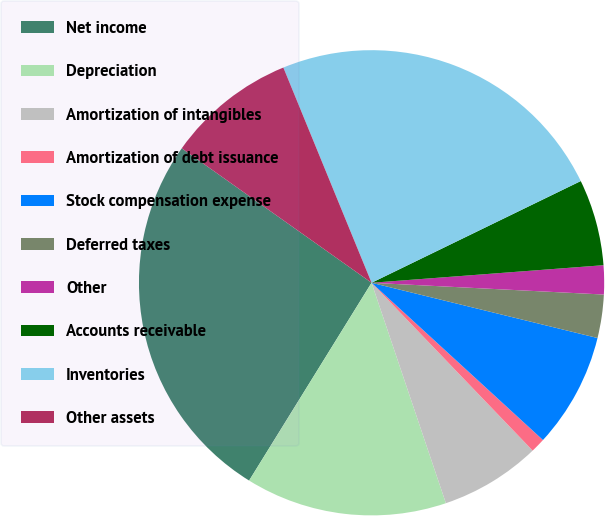Convert chart. <chart><loc_0><loc_0><loc_500><loc_500><pie_chart><fcel>Net income<fcel>Depreciation<fcel>Amortization of intangibles<fcel>Amortization of debt issuance<fcel>Stock compensation expense<fcel>Deferred taxes<fcel>Other<fcel>Accounts receivable<fcel>Inventories<fcel>Other assets<nl><fcel>25.99%<fcel>14.0%<fcel>7.0%<fcel>1.01%<fcel>8.0%<fcel>3.01%<fcel>2.01%<fcel>6.0%<fcel>23.99%<fcel>9.0%<nl></chart> 